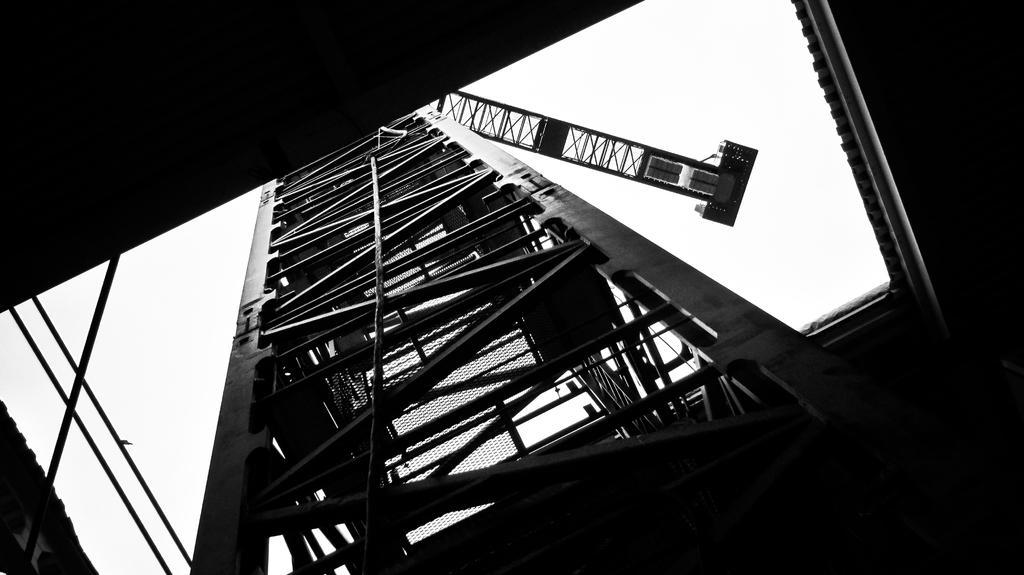How would you summarize this image in a sentence or two? In this image I can see a building, metal rods and the sky. This image is taken may be in a building. 